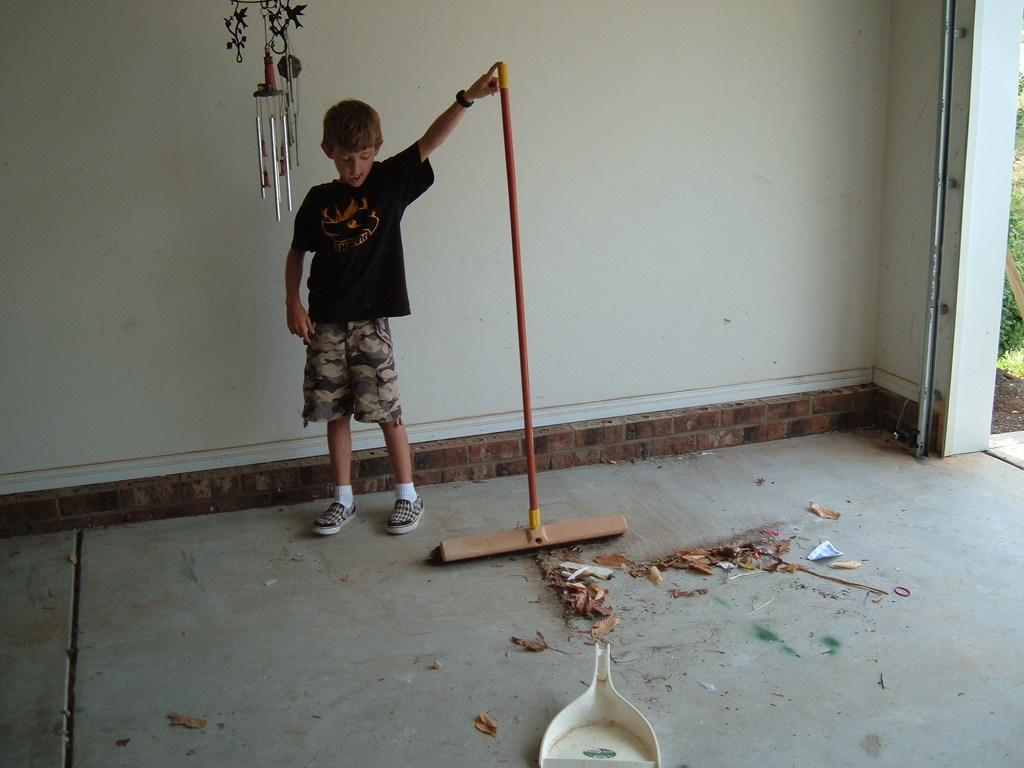Who is the main subject in the image? There is a boy in the image. What is the boy doing in the image? The boy is standing and holding a mop. What can be seen at the bottom of the image? There is dust and a tray at the bottom of the image. What is visible in the background of the image? There is a wall, a wind chime, and dust in the background of the image. How does the boy maintain his balance while performing a trick in the image? There is no trick being performed in the image, and the boy is simply standing while holding a mop. 